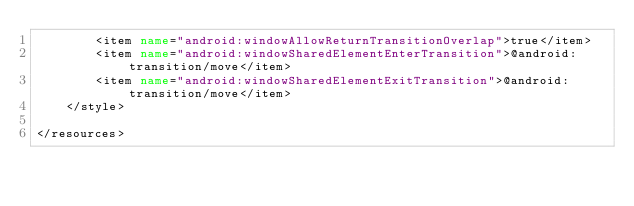<code> <loc_0><loc_0><loc_500><loc_500><_XML_>        <item name="android:windowAllowReturnTransitionOverlap">true</item>
        <item name="android:windowSharedElementEnterTransition">@android:transition/move</item>
        <item name="android:windowSharedElementExitTransition">@android:transition/move</item>
    </style>

</resources>
</code> 